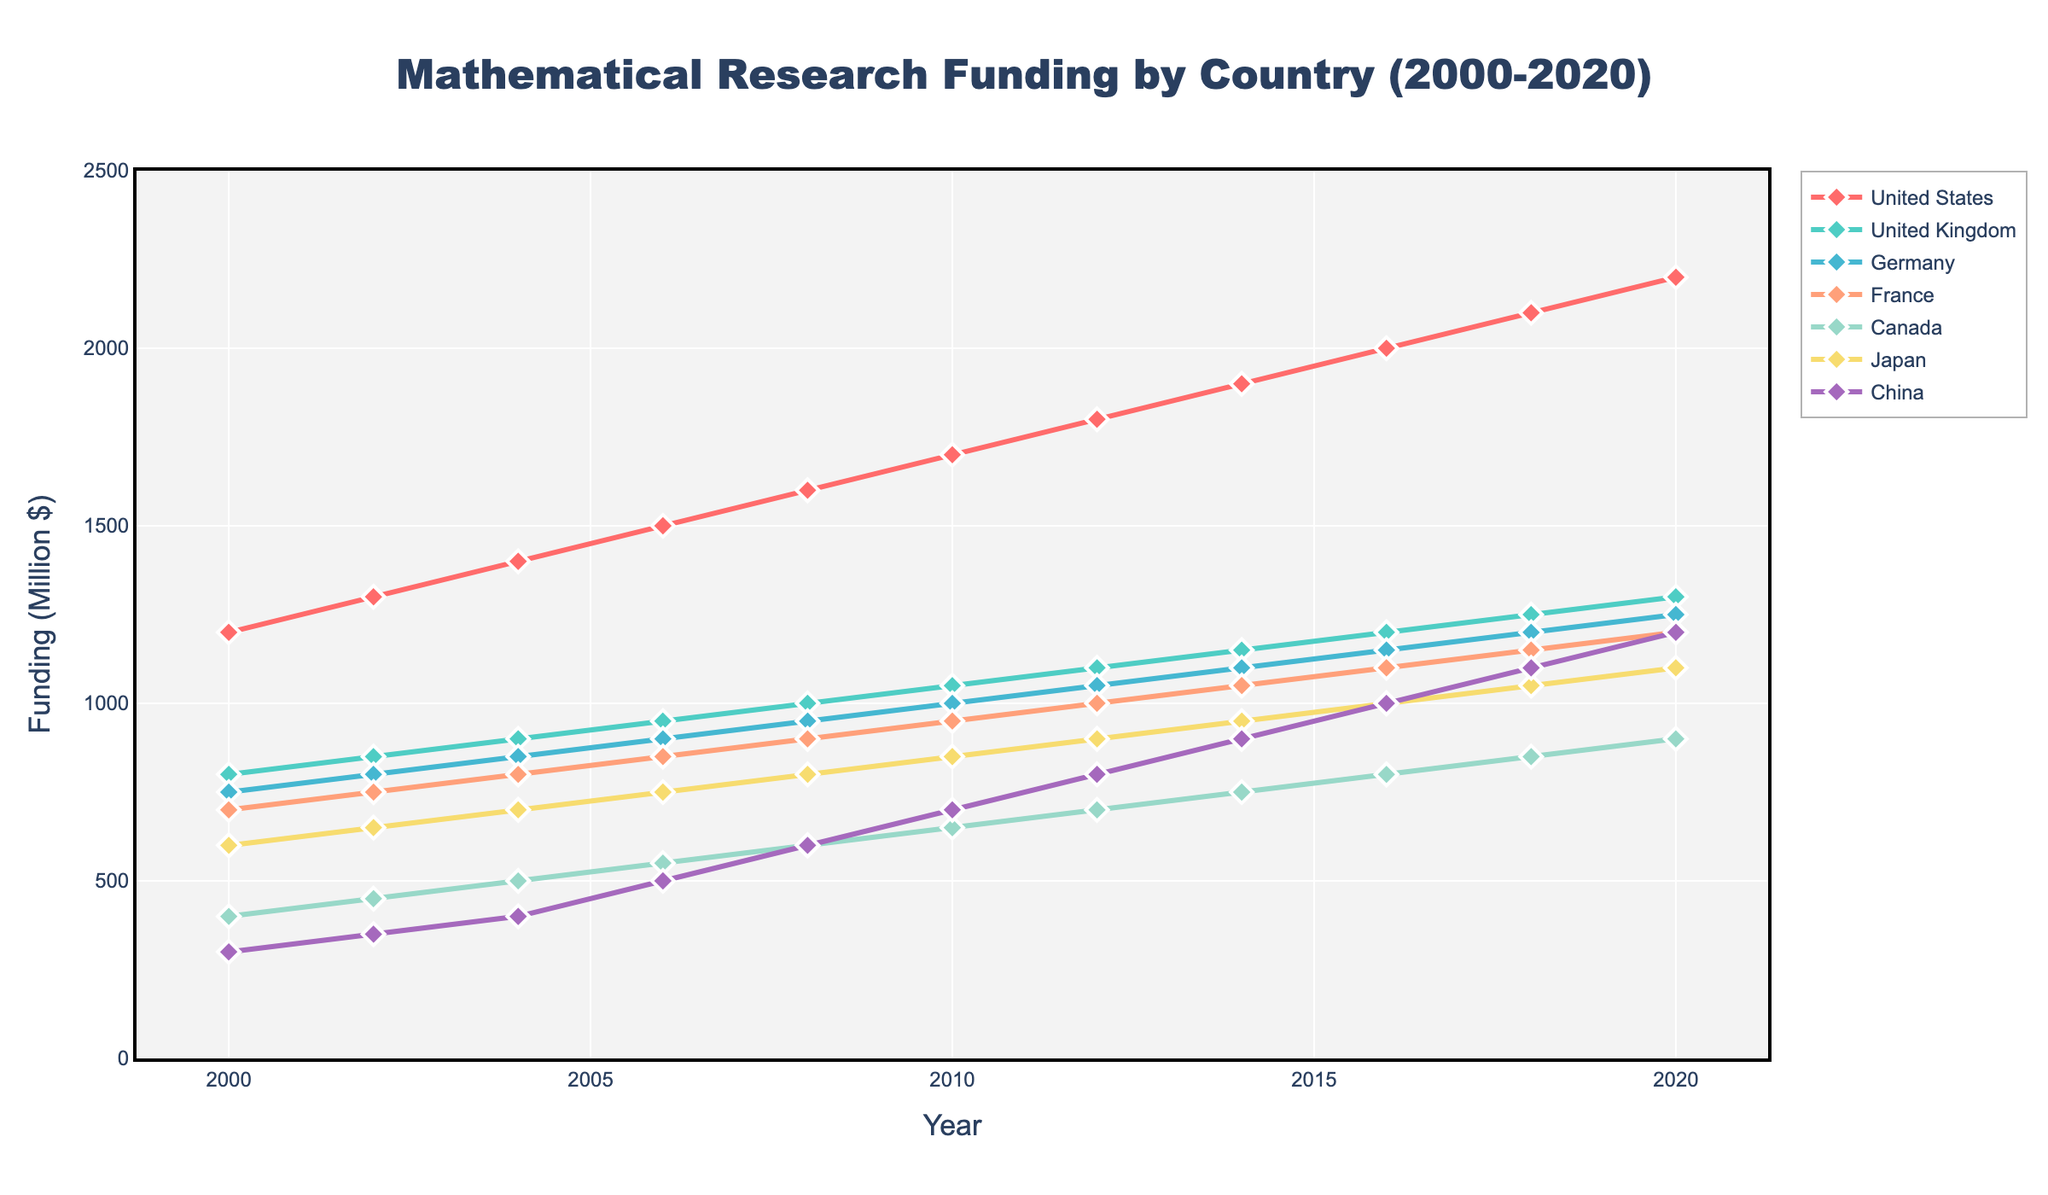What's the trend of mathematical research funding in the United States from 2000 to 2020? The line representing the United States shows a steady increase from 1200 million dollars in 2000 to 2200 million dollars in 2020, indicating a positive trend.
Answer: Steady increase When did China first surpass 1000 million dollars in funding? Observing the line for China, it first reaches 1000 million dollars in 2016.
Answer: 2016 Compare the funding in 2020 between France and Japan. Which received more funding, and by how much? In 2020, France had 1200 million dollars and Japan had 1100 million dollars. France received more, and the difference is 1200 - 1100 = 100 million dollars.
Answer: France by 100 million dollars In which year did Canada and Germany have the same funding, if any? By examining the lines for Canada and Germany, we notice they intersect at no point during the given years, indicating they never had the same funding amount.
Answer: Never What's the average funding for the United Kingdom over the given period? The UK's funding amounts are 800, 850, 900, 950, 1000, 1050, 1100, 1150, 1200, 1250, and 1300. Summing these values: 800 + 850 + 900 + 950 + 1000 + 1050 + 1100 + 1150 + 1200 + 1250 + 1300 = 12950. Dividing by 11 (years), the average is 12950 / 11 = approximately 1177.27 million dollars.
Answer: Approximately 1177.27 million dollars Which country saw the highest increase in funding from 2004 to 2008, and what was the increase? From 2004 to 2008, the funding in the United States increased from 1400 to 1600 (an increase of 200), the United Kingdom from 900 to 1000 (an increase of 100), and China from 400 to 600 (an increase of 200). So, China and the United States both saw the highest increase of 200 million dollars.
Answer: China and United States, 200 million dollars What is the difference in funding between the highest-funded and lowest-funded countries in 2020? In 2020, the highest-funded country was the United States with 2200 million dollars, and the lowest was Canada with 900 million dollars. The difference is 2200 - 900 = 1300 million dollars.
Answer: 1300 million dollars Identify the period when Germany had a consistent increase in funding without any decline. From 2000 to 2020, Germany showed a consistent increase in funding every year, without any decline.
Answer: 2000 to 2020 By how much did funding in Japan increase from 2000 to 2020? In 2000, Japan had 600 million dollars and in 2020, it had 1100 million dollars. The increase is 1100 - 600 = 500 million dollars.
Answer: 500 million dollars Which country had the steepest increase between the years 2008 and 2010? Between 2008 and 2010, the United States' funding increased from 1600 to 1700 (100 million increase), the United Kingdom from 1000 to 1050 (50 million increase), and China from 600 to 700 (100 million increase). Both the United States and China had the steepest increase of 100 million dollars.
Answer: United States and China 